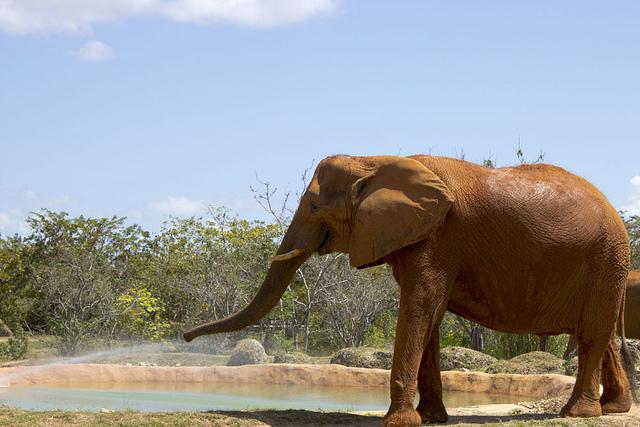Where do their trunks reach?
Concise answer only. Water. What is the animal standing next to?
Short answer required. Water. What does the sky look like?
Be succinct. Blue. Is something coming out of the elephant's trunk?
Concise answer only. Yes. What color is the elephant?
Short answer required. Brown. 